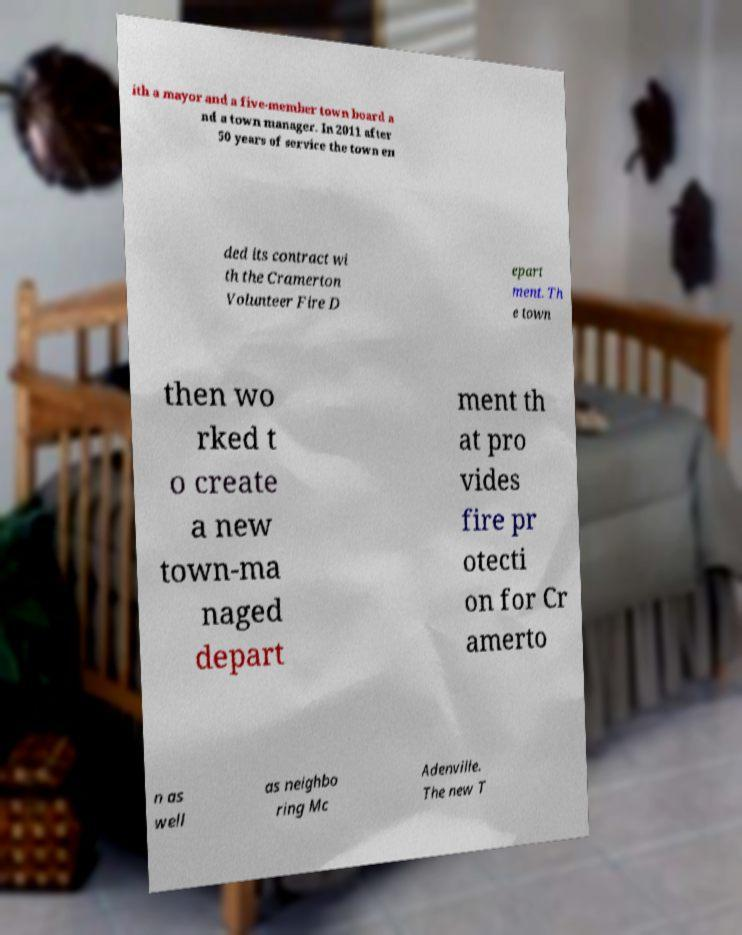Please read and relay the text visible in this image. What does it say? ith a mayor and a five-member town board a nd a town manager. In 2011 after 50 years of service the town en ded its contract wi th the Cramerton Volunteer Fire D epart ment. Th e town then wo rked t o create a new town-ma naged depart ment th at pro vides fire pr otecti on for Cr amerto n as well as neighbo ring Mc Adenville. The new T 